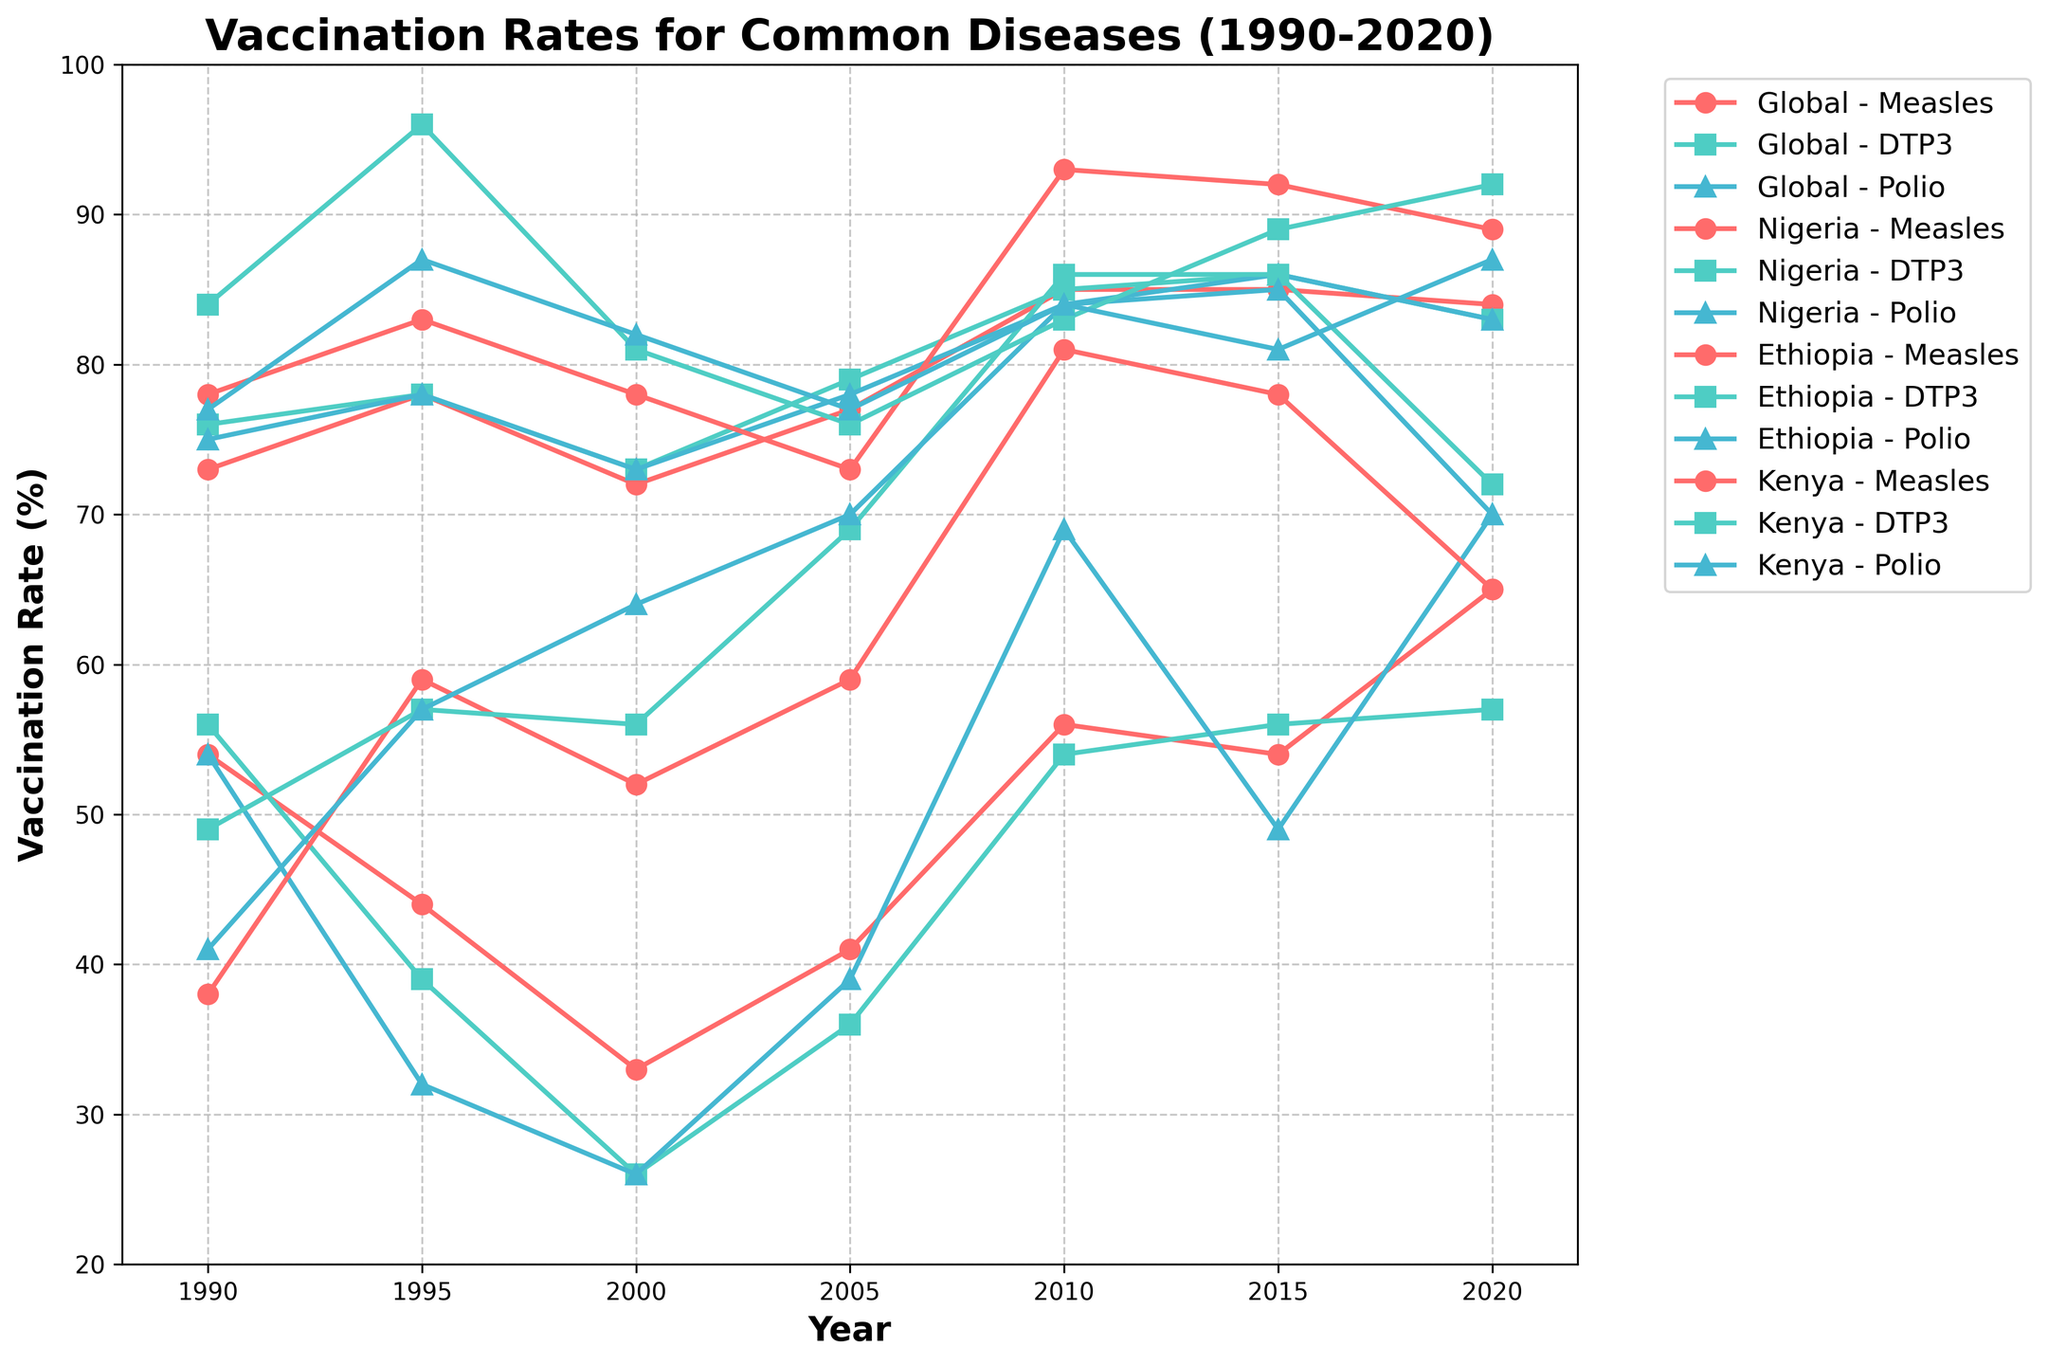What was the vaccination rate for Measles in Nigeria in the year 2000? Checking the figure, the vaccination rate for Measles in Nigeria in 2000 is marked at 33%.
Answer: 33% Which country had the highest vaccination rate for DTP3 in the year 1995? By examining the plot, we see that Kenya had the highest DTP3 vaccination rate in 1995, with a rate of 96%.
Answer: Kenya How has the vaccination rate for Polio changed in Ethiopia from 1990 to 2020? Looking at the graph, we see the Polio vaccination rate in Ethiopia increased from 41% in 1990 to 70% in 2020, a change of 29 percentage points.
Answer: Increased by 29 percentage points Comparing 2005 and 2010, what was the increase in the Measles vaccination rate in Ethiopia? According to the chart, the Measles vaccination rate in Ethiopia was 59% in 2005 and 81% in 2010. The increase is 81% - 59% = 22%.
Answer: 22% What was the difference between the global Polio vaccination rate and the Nigerian Polio vaccination rate in 2015? From the figure, the global Polio vaccination rate in 2015 was 86%, while the Nigerian Polio vaccination rate was 49%. The difference is 86% - 49% = 37%.
Answer: 37% Which disease had the smallest increase in global vaccination rates from 1990 to 2020? Out of the diseases shown, the measles vaccination rate increased from 73% in 1990 to 84% in 2020, a change of 11 percentage points. DTP3 increased by 7 percentage points, and Polio increased by 8 percentage points. Hence, DTP3 had the smallest increase.
Answer: DTP3 Which country had the highest vaccination rate for Measles in 2015? In the year 2015, the graph shows that Kenya had the highest Measles vaccination rate, at 92%.
Answer: Kenya What was the average vaccination rate for Polio in Nigeria from 1990 to 2020? The Polio vaccination rates in Nigeria for the years given are 54%, 32%, 26%, 39%, 69%, 49%, and 70%. Summing these, we get 339%. Dividing by 7 (the number of data points), the average is 339% / 7 ≈ 48.43%.
Answer: 48.43% Between 1990 and 2000, which country saw a decline in vaccination rate for Measles? From 1990 to 2000, the graph shows that Nigeria's Measles vaccination rate declined from 54% to 33%.
Answer: Nigeria What is the general trend of DTP3 vaccination rates in Kenya from 1990 to 2020? By looking at the figure, the DTP3 vaccination rate in Kenya fluctuated but generally stayed high, reaching a peak at 96% in 1995 and maintaining a rate above 70% in other years.
Answer: Stable and high 